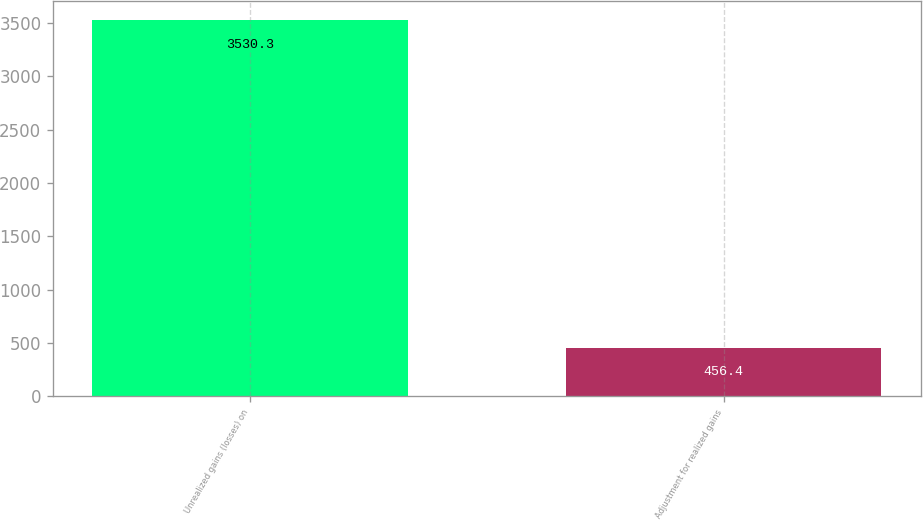Convert chart to OTSL. <chart><loc_0><loc_0><loc_500><loc_500><bar_chart><fcel>Unrealized gains (losses) on<fcel>Adjustment for realized gains<nl><fcel>3530.3<fcel>456.4<nl></chart> 